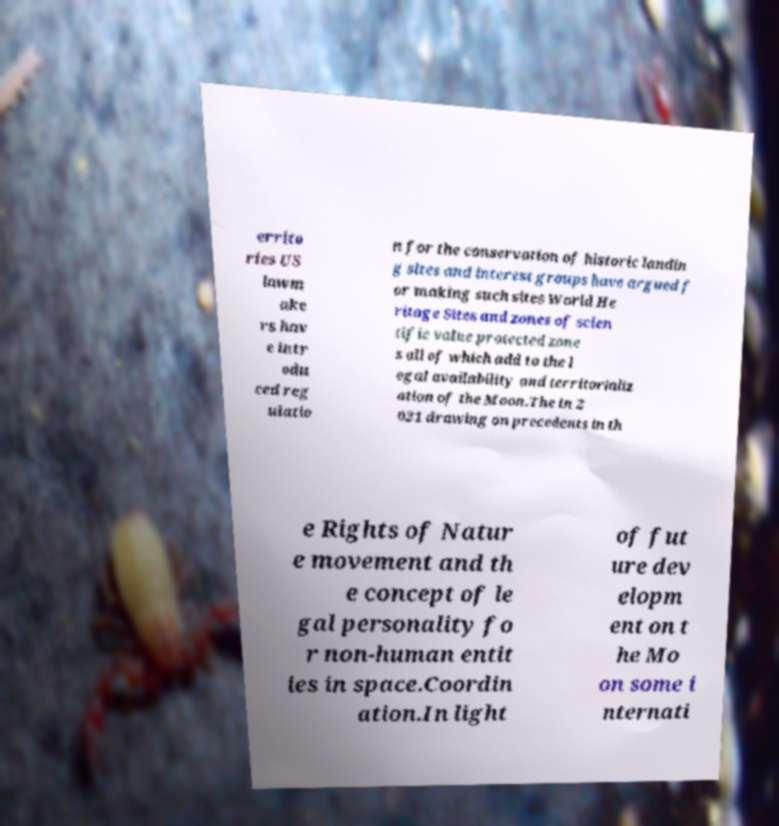Can you accurately transcribe the text from the provided image for me? errito ries US lawm ake rs hav e intr odu ced reg ulatio n for the conservation of historic landin g sites and interest groups have argued f or making such sites World He ritage Sites and zones of scien tific value protected zone s all of which add to the l egal availability and territorializ ation of the Moon.The in 2 021 drawing on precedents in th e Rights of Natur e movement and th e concept of le gal personality fo r non-human entit ies in space.Coordin ation.In light of fut ure dev elopm ent on t he Mo on some i nternati 